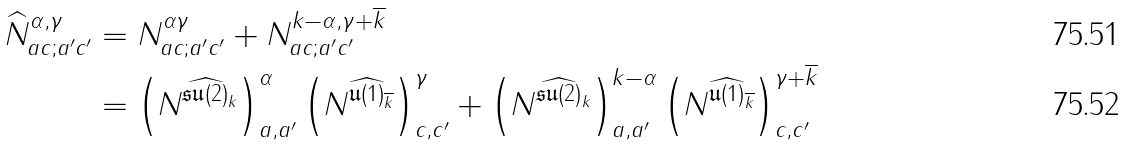<formula> <loc_0><loc_0><loc_500><loc_500>\widehat { N } _ { a c ; a ^ { \prime } c ^ { \prime } } ^ { \alpha , \gamma } & = N _ { a c ; a ^ { \prime } c ^ { \prime } } ^ { \alpha \gamma } + N _ { a c ; a ^ { \prime } c ^ { \prime } } ^ { k - \alpha , \gamma + \overline { k } } \\ & = \left ( N ^ { \widehat { \mathfrak { s u } ( 2 ) } _ { k } } \right ) ^ { \alpha } _ { a , a ^ { \prime } } \left ( N ^ { \widehat { \mathfrak { u } ( 1 ) } _ { \overline { k } } } \right ) ^ { \gamma } _ { c , c ^ { \prime } } + \left ( N ^ { \widehat { \mathfrak { s u } ( 2 ) } _ { k } } \right ) ^ { k - \alpha } _ { a , a ^ { \prime } } \left ( N ^ { \widehat { \mathfrak { u } ( 1 ) } _ { \overline { k } } } \right ) ^ { \gamma + \overline { k } } _ { c , c ^ { \prime } }</formula> 